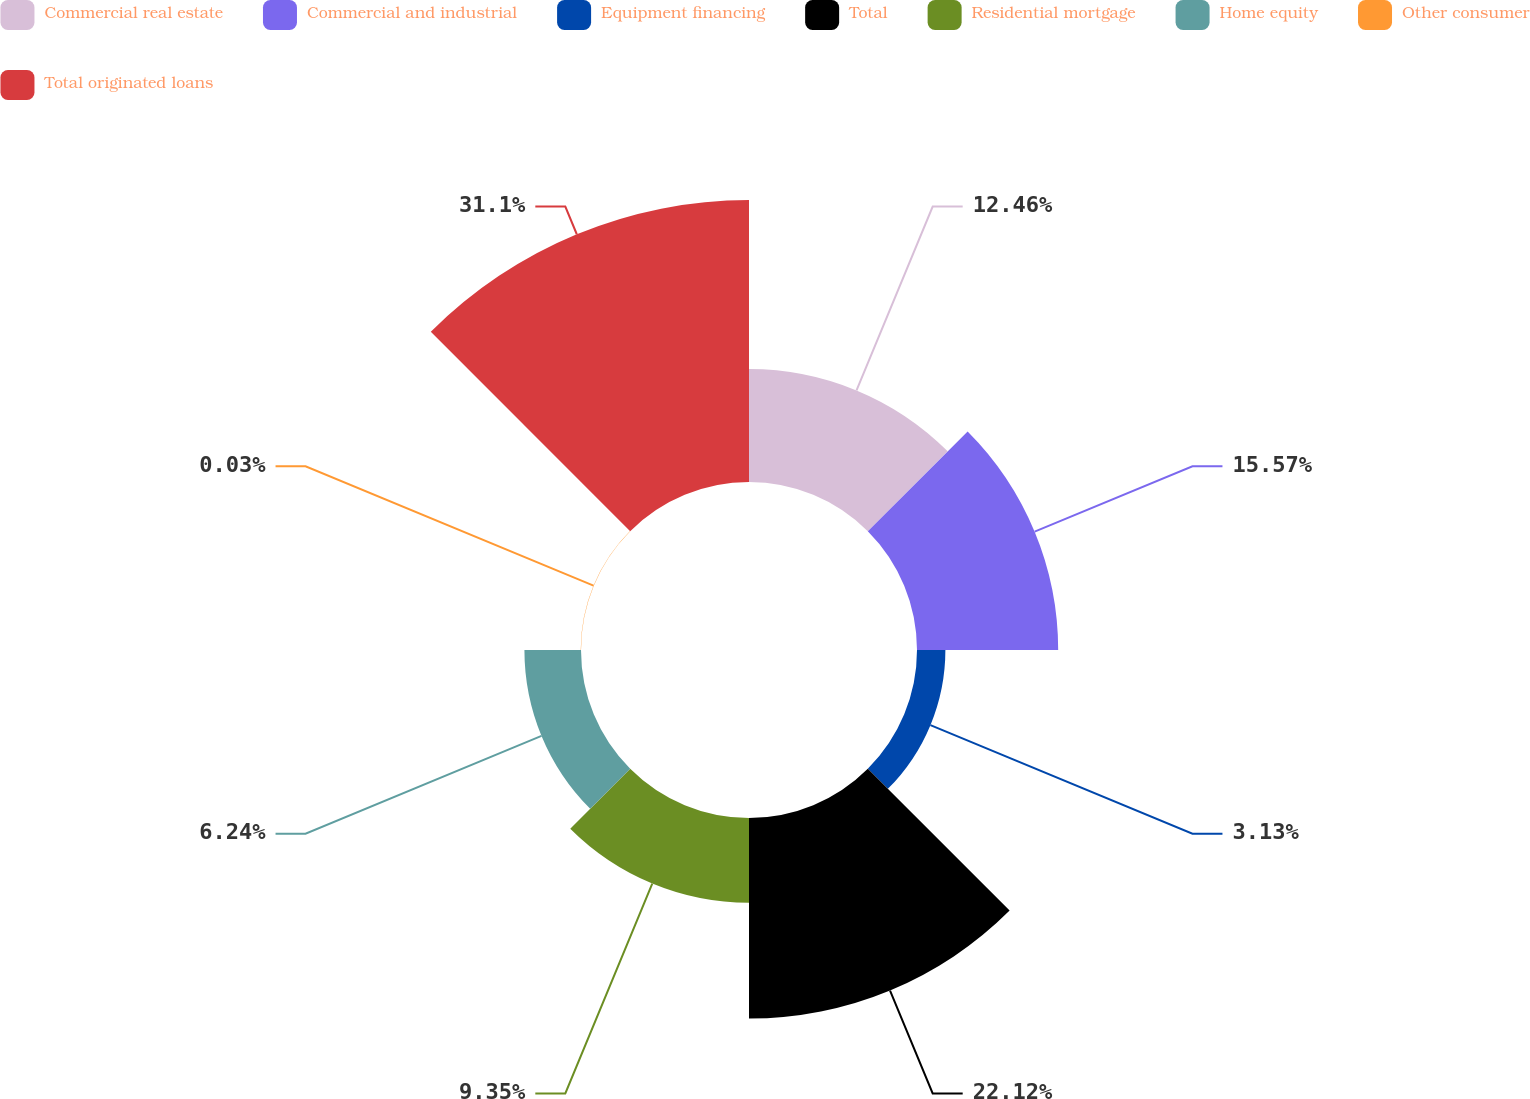<chart> <loc_0><loc_0><loc_500><loc_500><pie_chart><fcel>Commercial real estate<fcel>Commercial and industrial<fcel>Equipment financing<fcel>Total<fcel>Residential mortgage<fcel>Home equity<fcel>Other consumer<fcel>Total originated loans<nl><fcel>12.46%<fcel>15.57%<fcel>3.13%<fcel>22.12%<fcel>9.35%<fcel>6.24%<fcel>0.03%<fcel>31.1%<nl></chart> 